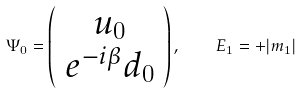Convert formula to latex. <formula><loc_0><loc_0><loc_500><loc_500>\Psi _ { 0 } = \left ( \begin{array} { c } u _ { 0 } \\ e ^ { - i \beta } d _ { 0 } \end{array} \right ) , \quad E _ { 1 } = + | m _ { 1 } |</formula> 